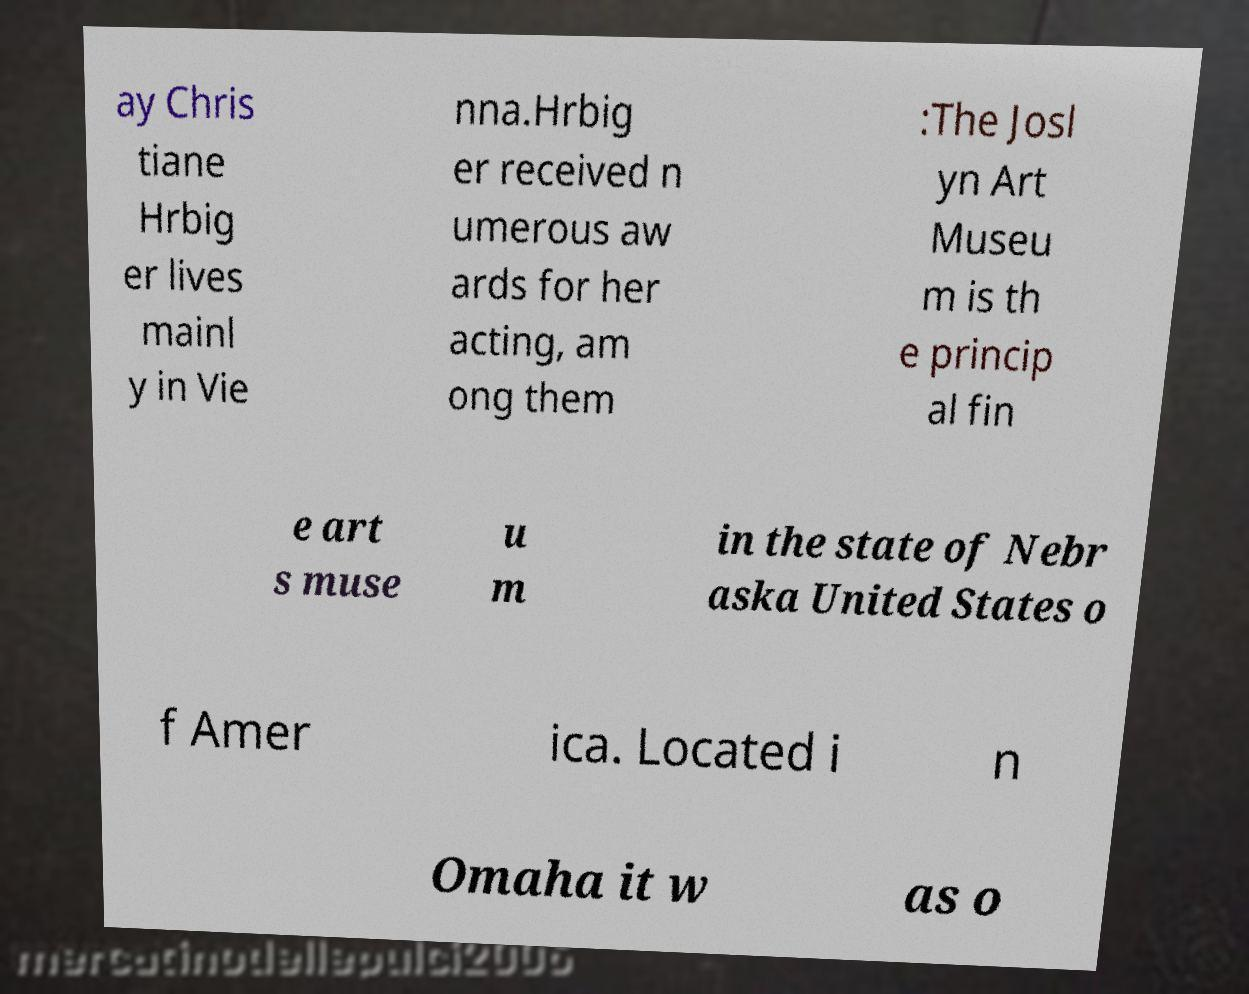Can you accurately transcribe the text from the provided image for me? ay Chris tiane Hrbig er lives mainl y in Vie nna.Hrbig er received n umerous aw ards for her acting, am ong them :The Josl yn Art Museu m is th e princip al fin e art s muse u m in the state of Nebr aska United States o f Amer ica. Located i n Omaha it w as o 